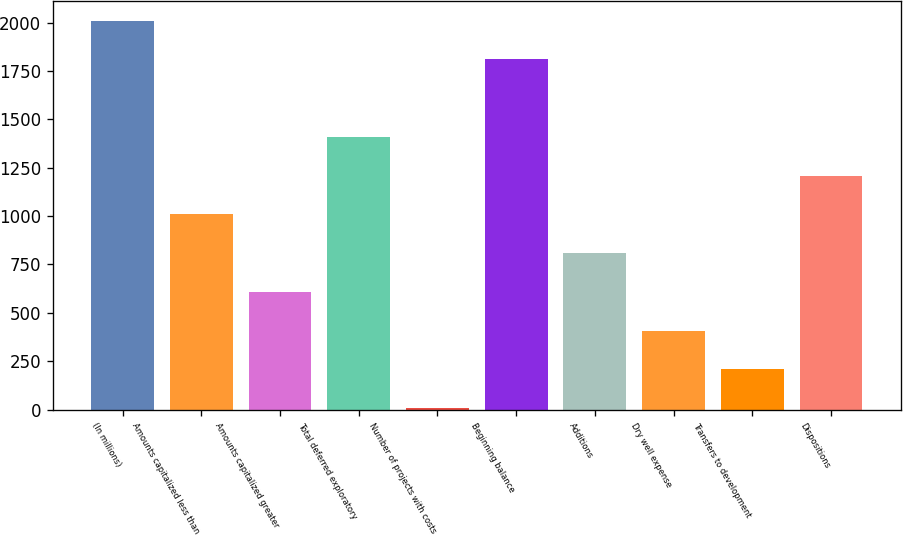Convert chart to OTSL. <chart><loc_0><loc_0><loc_500><loc_500><bar_chart><fcel>(In millions)<fcel>Amounts capitalized less than<fcel>Amounts capitalized greater<fcel>Total deferred exploratory<fcel>Number of projects with costs<fcel>Beginning balance<fcel>Additions<fcel>Dry well expense<fcel>Transfers to development<fcel>Dispositions<nl><fcel>2010<fcel>1008.5<fcel>607.9<fcel>1409.1<fcel>7<fcel>1809.7<fcel>808.2<fcel>407.6<fcel>207.3<fcel>1208.8<nl></chart> 